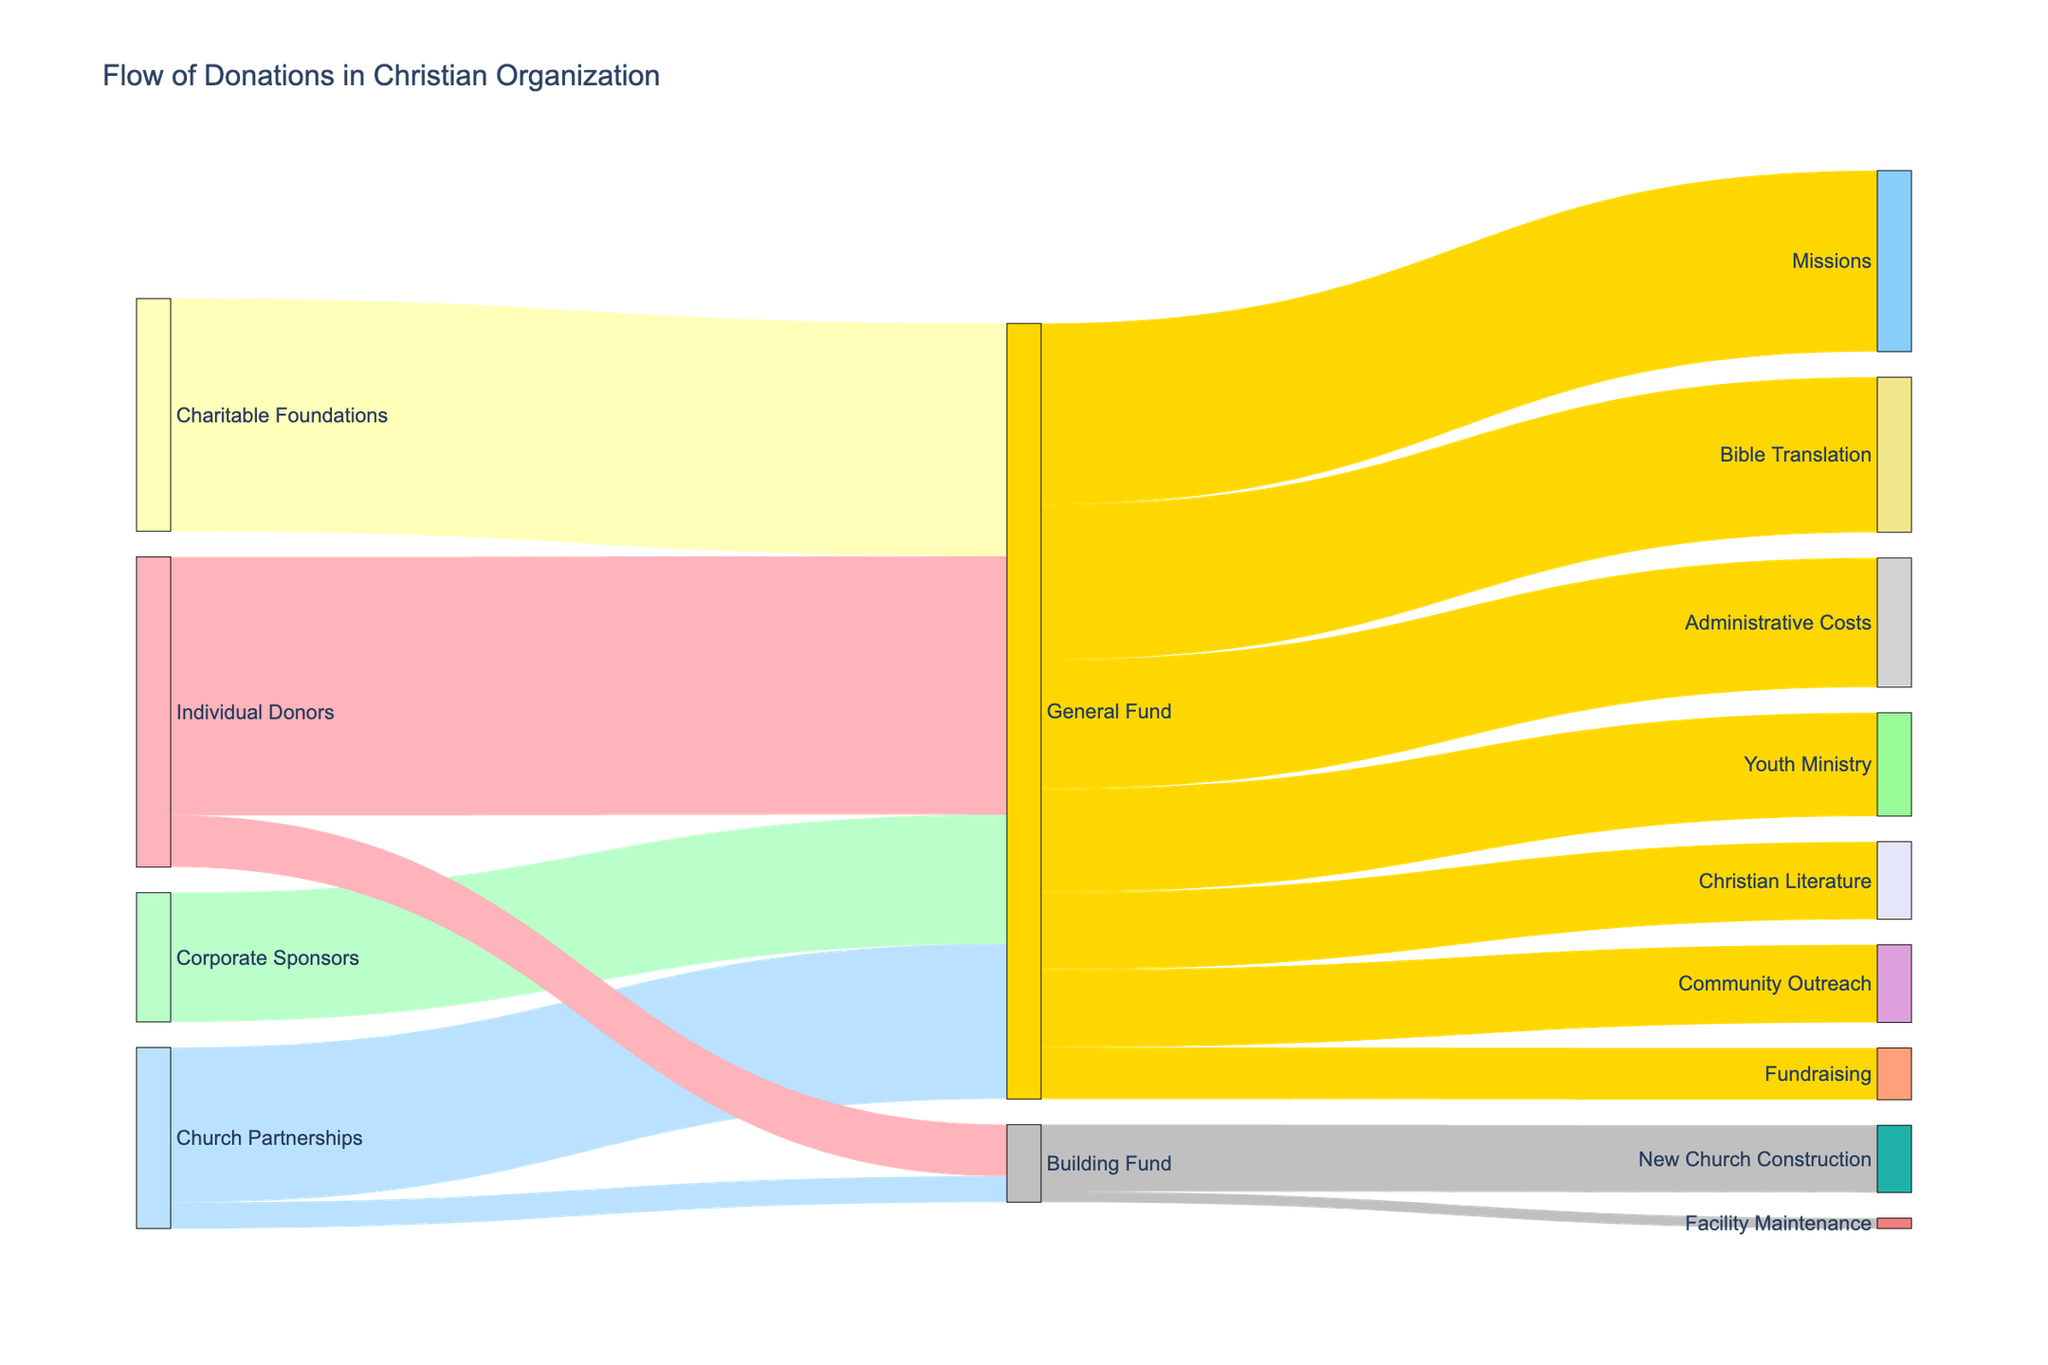What is the title of the figure? The title is usually located at the top of the figure. In this case, it states "Flow of Donations in Christian Organization".
Answer: Flow of Donations in Christian Organization How many sources of donations are contributing to the General Fund? By looking at the Sankey diagram, identify the sources that contribute to the General Fund. There are four sources: Individual Donors, Corporate Sponsors, Church Partnerships, and Charitable Foundations.
Answer: 4 What is the total amount of donations received by the General Fund? Sum the values of the donations received by the General Fund: 500,000 (Individual Donors) + 250,000 (Corporate Sponsors) + 300,000 (Church Partnerships) + 450,000 (Charitable Foundations) = 1,500,000.
Answer: 1,500,000 Which ministry program receives the highest amount from the General Fund? Compare the values of donations flowing from the General Fund to each ministry program. The Missions program receives the highest amount at 350,000.
Answer: Missions What is the total amount allocated to ministry programs from the General Fund? Sum the values allocated to each ministry program: 200,000 (Youth Ministry) + 350,000 (Missions) + 150,000 (Community Outreach) + 300,000 (Bible Translation) + 150,000 (Christian Literature) = 1,150,000.
Answer: 1,150,000 What is the difference in the amount allocated to Administrative Costs and Fundraising from the General Fund? Subtract the Fundraising allocation from the Administrative Costs allocation: 250,000 (Administrative Costs) - 100,000 (Fundraising) = 150,000.
Answer: 150,000 How much is allocated to the New Church Construction from the Building Fund? Trace the flow from the Building Fund to different targets. The New Church Construction receives 130,000.
Answer: 130,000 What percentage of the General Fund is used for operational costs? Calculate the total allocated to operational costs (Administrative Costs and Fundraising) and then divide by the total General Fund amount, then multiply by 100. (250,000 + 100,000) / 1,500,000 * 100 = 23.33%.
Answer: 23.33% How does the donation from Individual Donors to the Building Fund compare to the donation from Church Partnerships to the Building Fund? Compare the two values: Individual Donors give 100,000 while Church Partnerships give 50,000 to the Building Fund. Individual Donors contribute twice as much.
Answer: Individual Donors contribute twice as much 